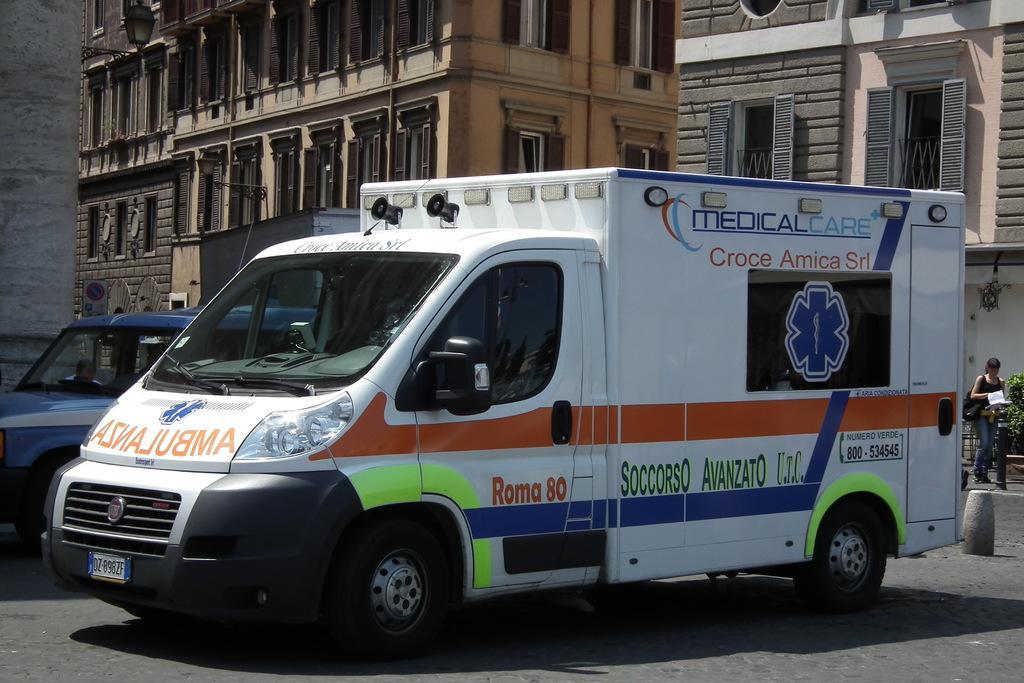How would you summarize this image in a sentence or two? In this picture we can see vehicles on the road and a woman carrying a bag and holding a book with her hand and standing and in the background we can see buildings with windows. 